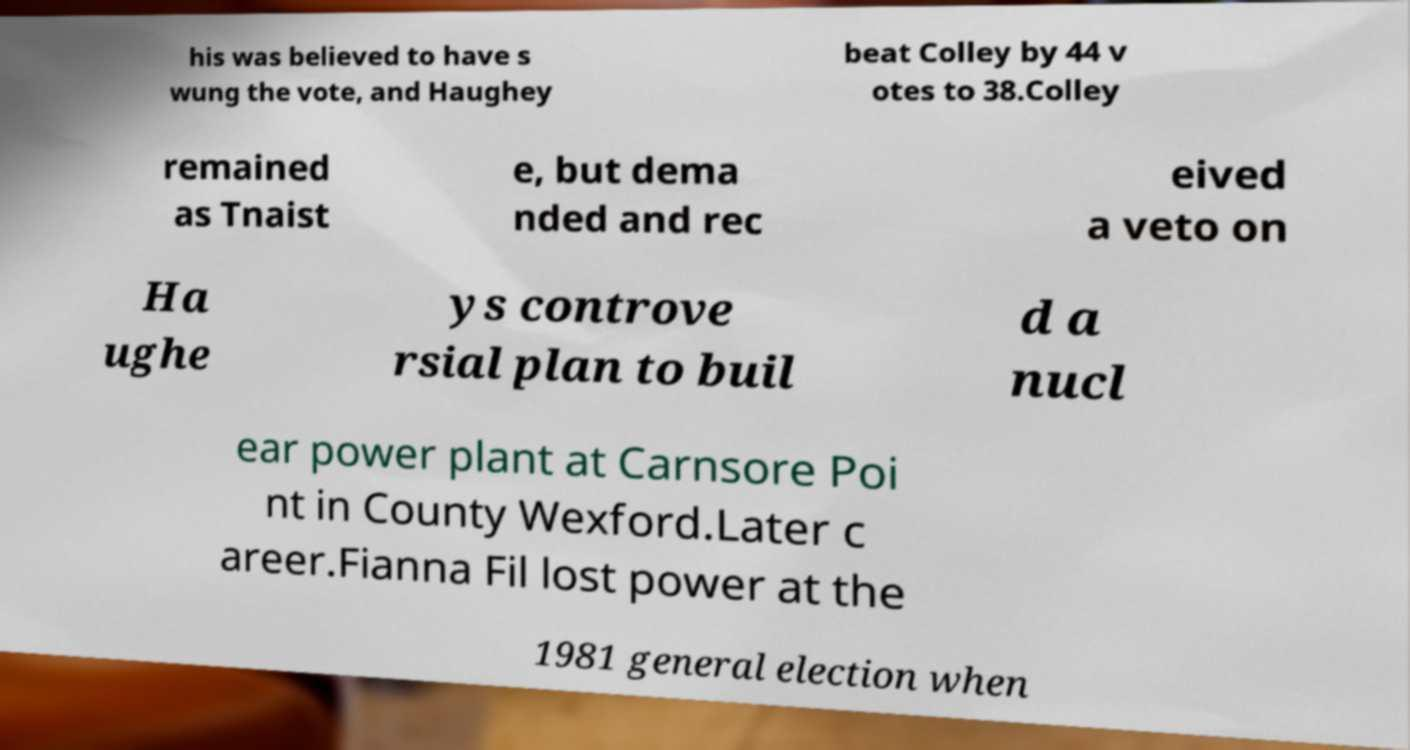Could you extract and type out the text from this image? his was believed to have s wung the vote, and Haughey beat Colley by 44 v otes to 38.Colley remained as Tnaist e, but dema nded and rec eived a veto on Ha ughe ys controve rsial plan to buil d a nucl ear power plant at Carnsore Poi nt in County Wexford.Later c areer.Fianna Fil lost power at the 1981 general election when 